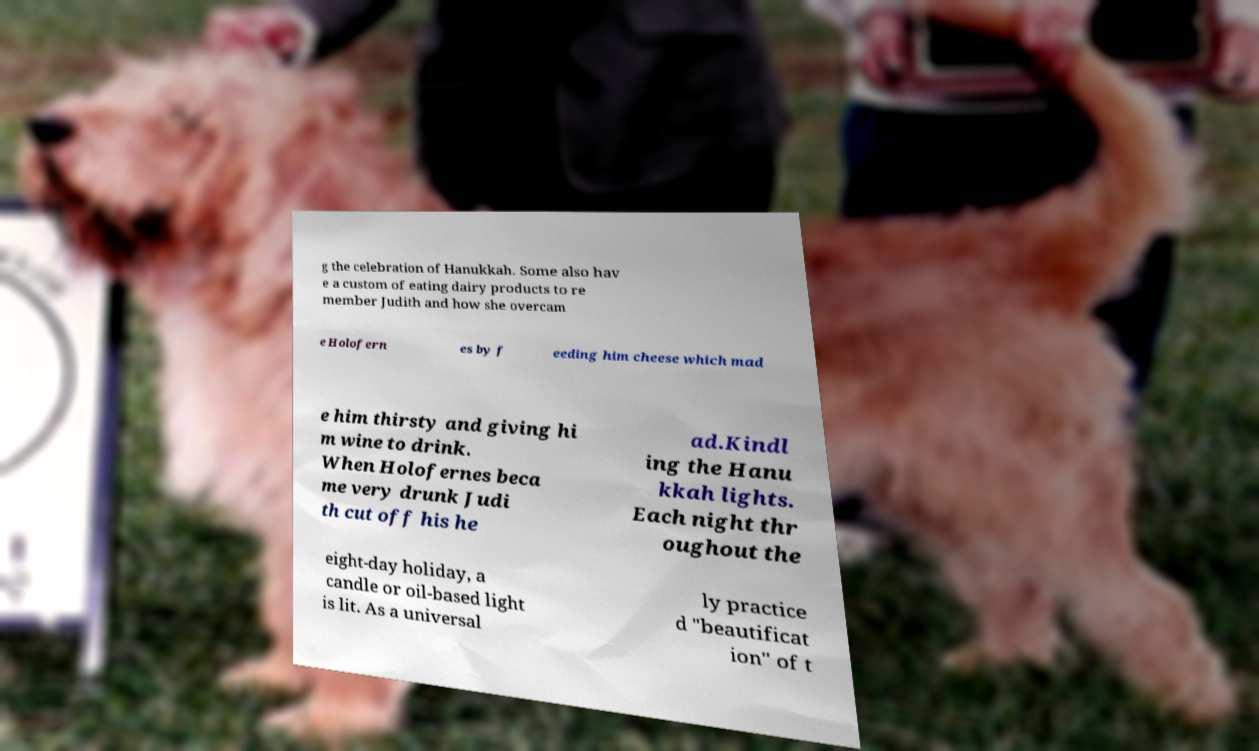For documentation purposes, I need the text within this image transcribed. Could you provide that? g the celebration of Hanukkah. Some also hav e a custom of eating dairy products to re member Judith and how she overcam e Holofern es by f eeding him cheese which mad e him thirsty and giving hi m wine to drink. When Holofernes beca me very drunk Judi th cut off his he ad.Kindl ing the Hanu kkah lights. Each night thr oughout the eight-day holiday, a candle or oil-based light is lit. As a universal ly practice d "beautificat ion" of t 